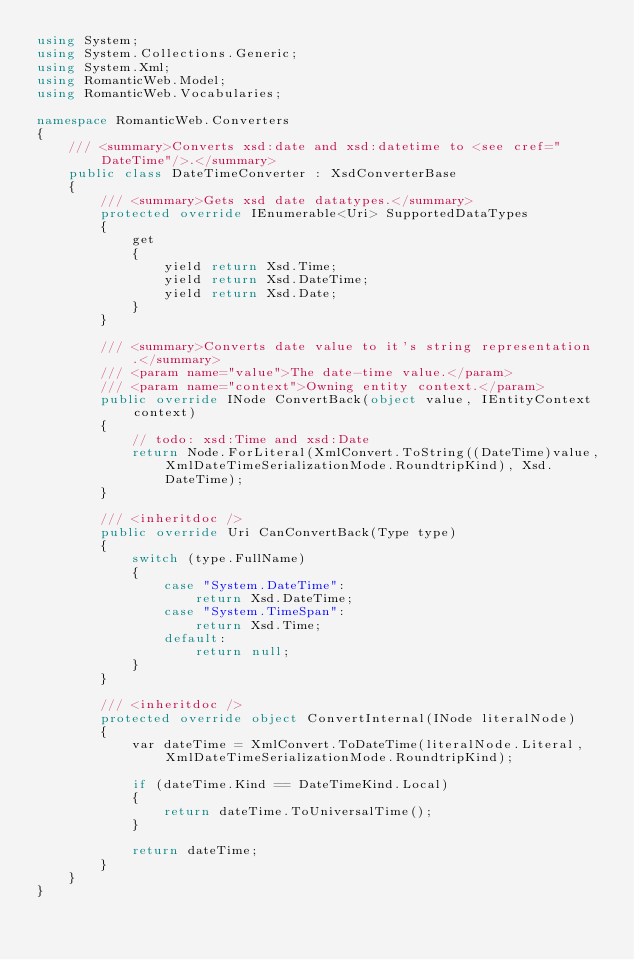<code> <loc_0><loc_0><loc_500><loc_500><_C#_>using System;
using System.Collections.Generic;
using System.Xml;
using RomanticWeb.Model;
using RomanticWeb.Vocabularies;

namespace RomanticWeb.Converters
{
    /// <summary>Converts xsd:date and xsd:datetime to <see cref="DateTime"/>.</summary>
    public class DateTimeConverter : XsdConverterBase
    {
        /// <summary>Gets xsd date datatypes.</summary>
        protected override IEnumerable<Uri> SupportedDataTypes
        {
            get
            {
                yield return Xsd.Time;
                yield return Xsd.DateTime;
                yield return Xsd.Date;
            }
        }

        /// <summary>Converts date value to it's string representation.</summary>
        /// <param name="value">The date-time value.</param>
        /// <param name="context">Owning entity context.</param>
        public override INode ConvertBack(object value, IEntityContext context)
        {
            // todo: xsd:Time and xsd:Date
            return Node.ForLiteral(XmlConvert.ToString((DateTime)value, XmlDateTimeSerializationMode.RoundtripKind), Xsd.DateTime);
        }

        /// <inheritdoc />
        public override Uri CanConvertBack(Type type)
        {
            switch (type.FullName)
            {
                case "System.DateTime":
                    return Xsd.DateTime;
                case "System.TimeSpan":
                    return Xsd.Time;
                default:
                    return null;
            }
        }

        /// <inheritdoc />
        protected override object ConvertInternal(INode literalNode)
        {
            var dateTime = XmlConvert.ToDateTime(literalNode.Literal, XmlDateTimeSerializationMode.RoundtripKind);

            if (dateTime.Kind == DateTimeKind.Local)
            {
                return dateTime.ToUniversalTime();
            }

            return dateTime;
        }
    }
}</code> 